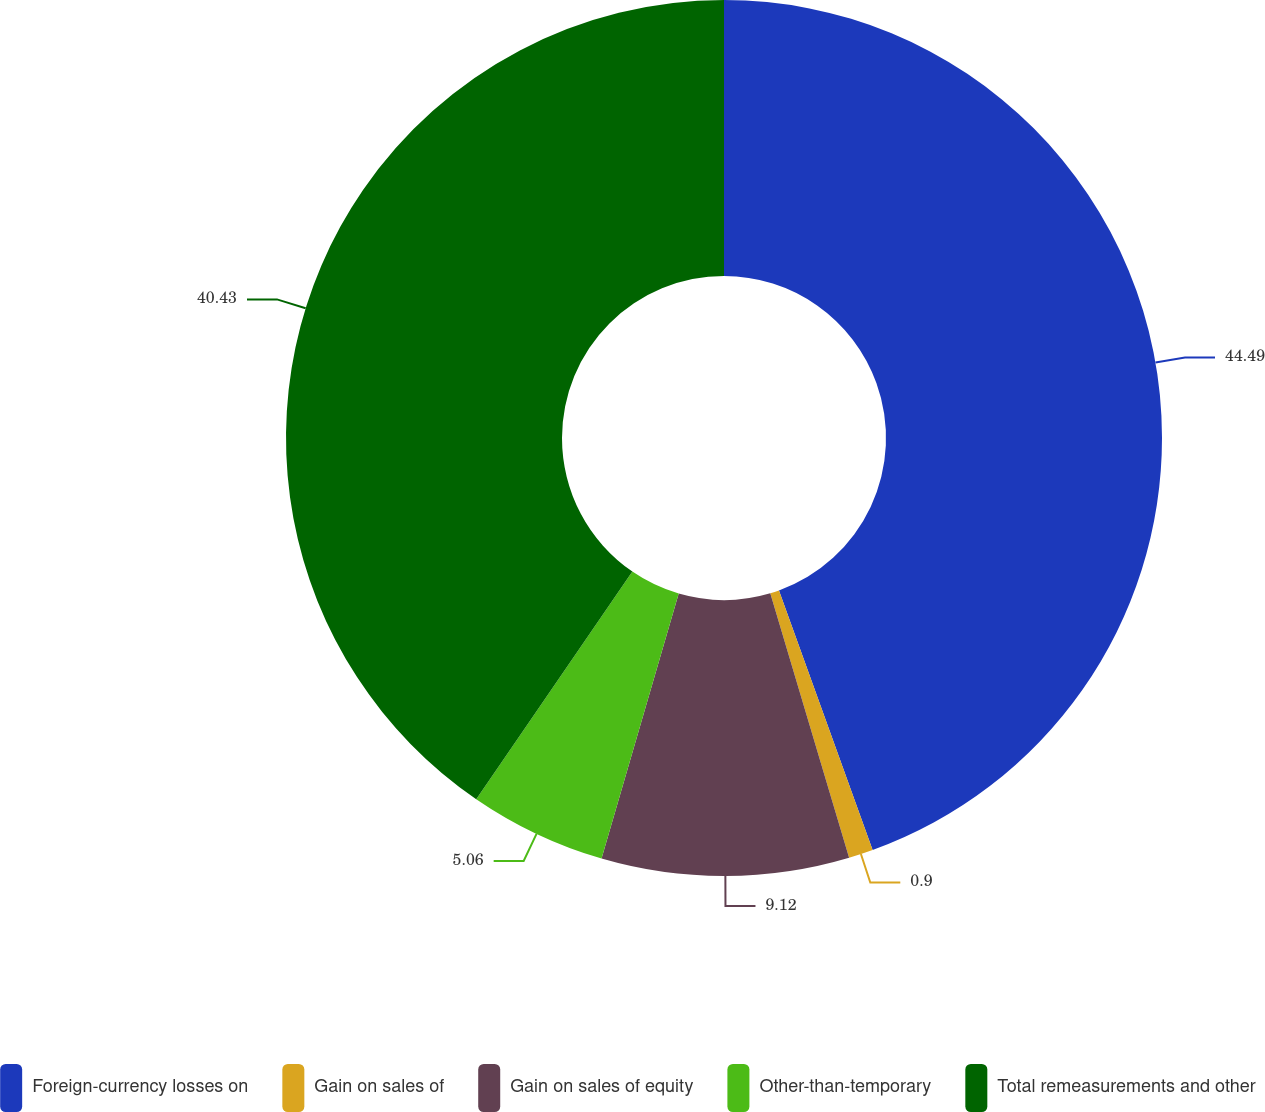Convert chart to OTSL. <chart><loc_0><loc_0><loc_500><loc_500><pie_chart><fcel>Foreign-currency losses on<fcel>Gain on sales of<fcel>Gain on sales of equity<fcel>Other-than-temporary<fcel>Total remeasurements and other<nl><fcel>44.49%<fcel>0.9%<fcel>9.12%<fcel>5.06%<fcel>40.43%<nl></chart> 